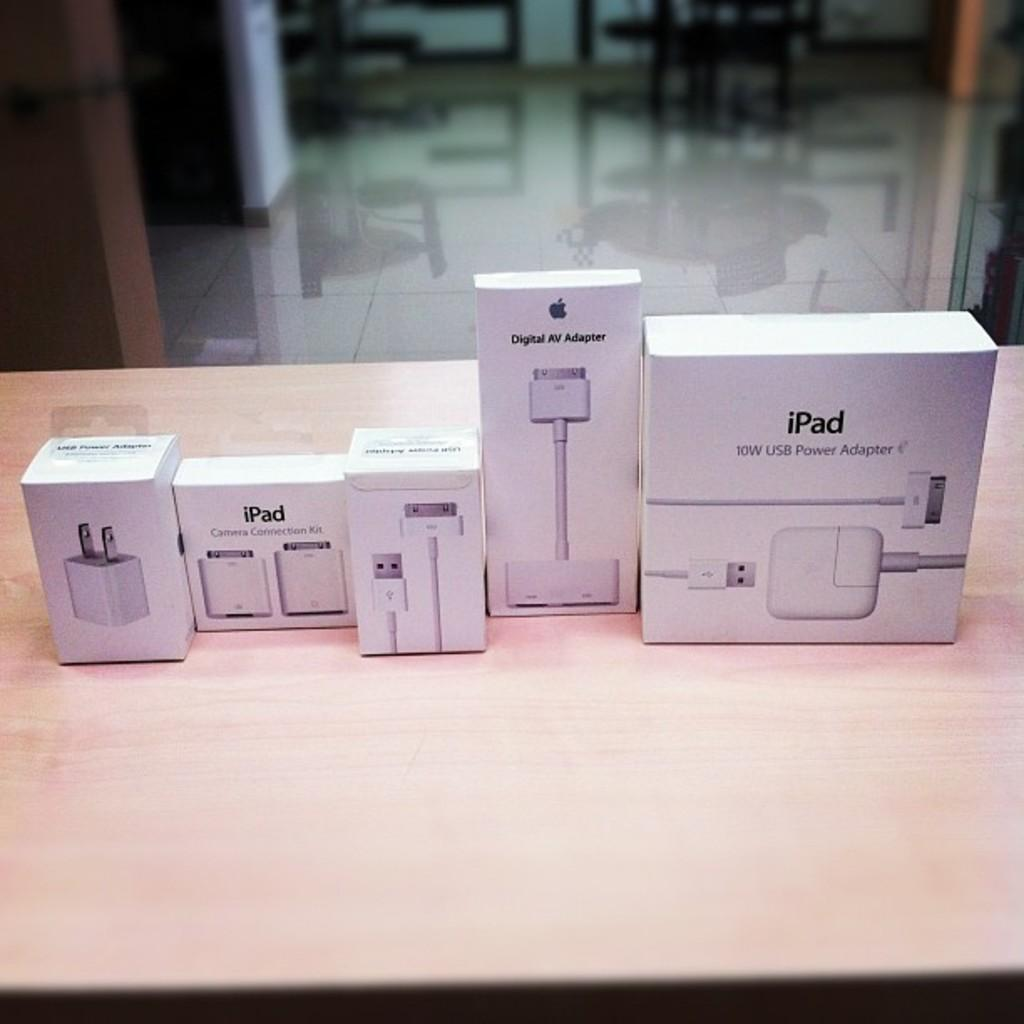<image>
Create a compact narrative representing the image presented. a row of Apple product boxes including iPad and cables 